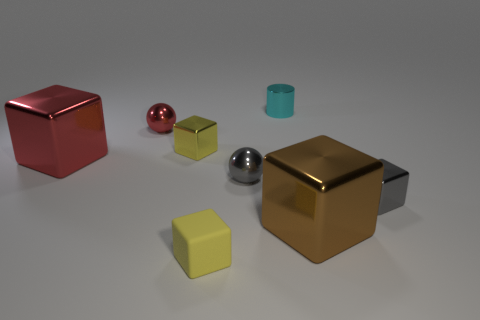Is the number of big red shiny cubes on the right side of the red metal block less than the number of small purple cylinders?
Your answer should be very brief. No. Is there a gray thing that is on the left side of the yellow matte block that is left of the gray metallic cube?
Provide a short and direct response. No. Are there any other things that have the same shape as the cyan object?
Offer a very short reply. No. Does the gray metal sphere have the same size as the brown metal cube?
Offer a very short reply. No. There is a yellow cube that is in front of the sphere that is in front of the metallic object that is left of the tiny red shiny ball; what is its material?
Give a very brief answer. Rubber. Are there the same number of big shiny blocks behind the small red metallic ball and small yellow rubber balls?
Offer a terse response. Yes. Is there anything else that has the same size as the red ball?
Provide a succinct answer. Yes. How many objects are either cyan things or blue metallic blocks?
Provide a succinct answer. 1. There is a yellow object that is the same material as the tiny cylinder; what is its shape?
Offer a very short reply. Cube. There is a yellow cube that is left of the yellow block that is in front of the gray block; what is its size?
Keep it short and to the point. Small. 